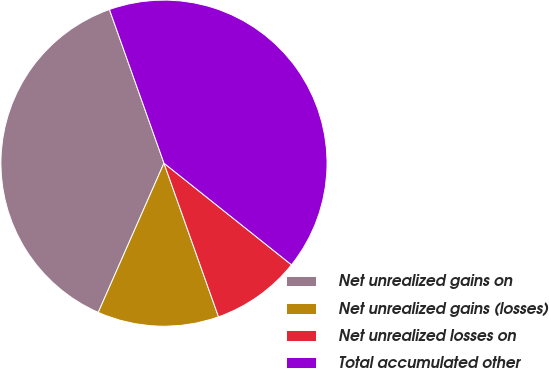<chart> <loc_0><loc_0><loc_500><loc_500><pie_chart><fcel>Net unrealized gains on<fcel>Net unrealized gains (losses)<fcel>Net unrealized losses on<fcel>Total accumulated other<nl><fcel>37.97%<fcel>12.03%<fcel>8.86%<fcel>41.14%<nl></chart> 